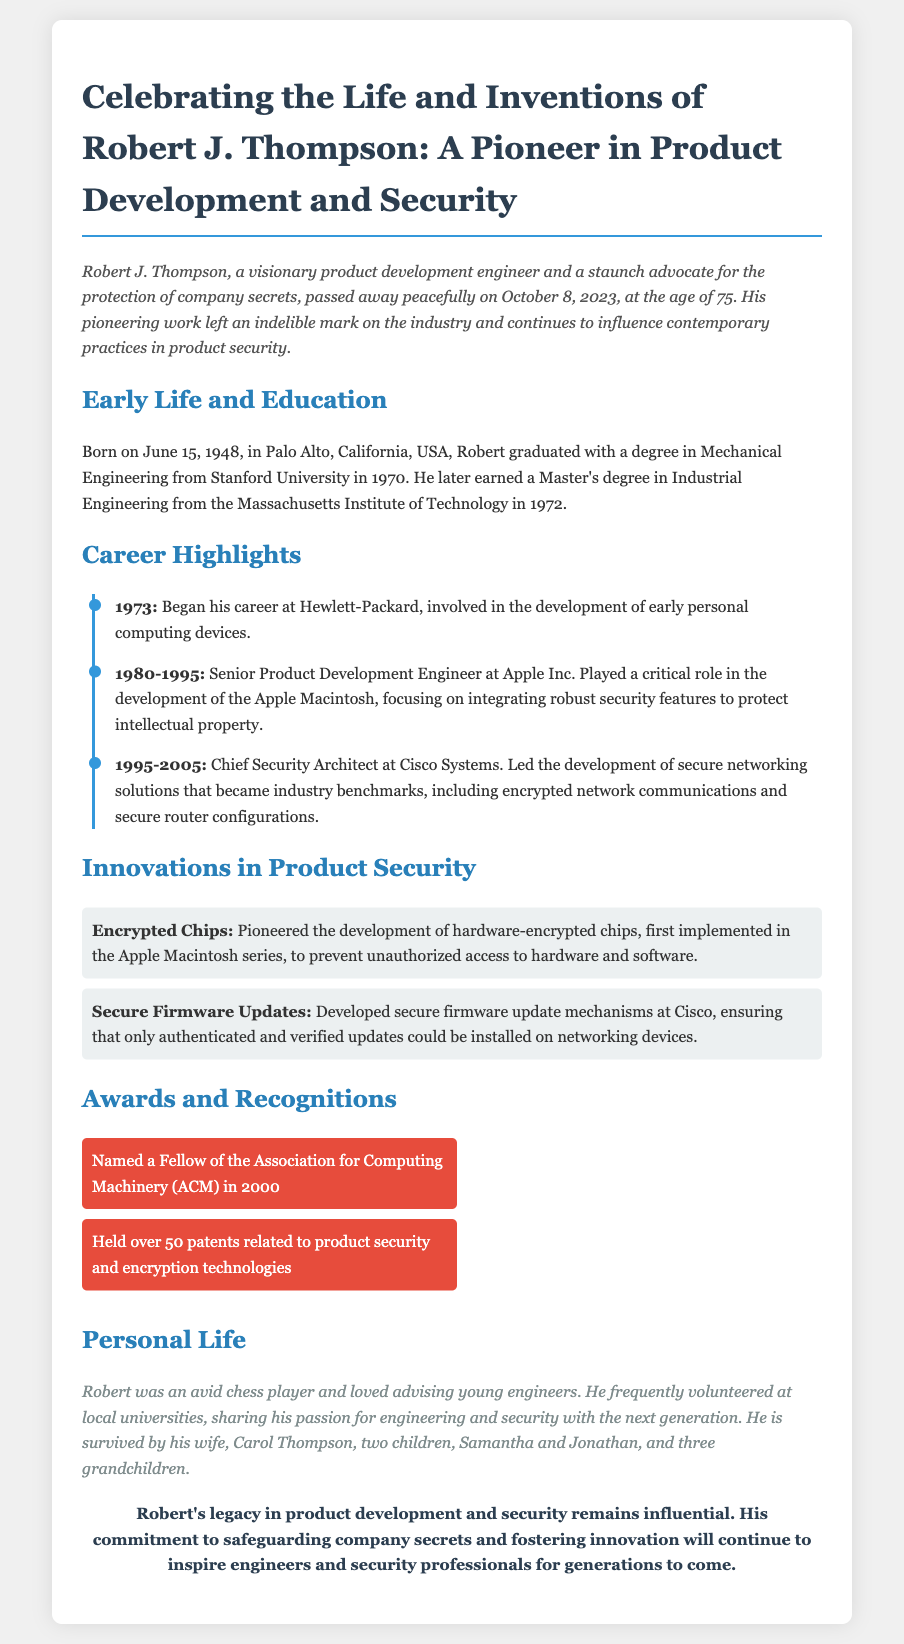What was Robert J. Thompson's birth date? The birth date is mentioned in the Early Life section of the obituary, which states June 15, 1948.
Answer: June 15, 1948 What company did Robert start his career with? The document states that Robert began his career at Hewlett-Packard.
Answer: Hewlett-Packard How many patents did Robert hold related to product security? The document indicates that he held over 50 patents related to product security and encryption technologies.
Answer: Over 50 What significant product did Robert contribute to at Apple Inc.? The obituary mentions that Robert played a critical role in the development of the Apple Macintosh.
Answer: Apple Macintosh What innovative product feature did Robert pioneer in the Apple Macintosh series? The document states that he pioneered the development of hardware-encrypted chips.
Answer: Hardware-encrypted chips What recognition did Robert receive in 2000? The document mentions that he was named a Fellow of the Association for Computing Machinery (ACM) in 2000.
Answer: Fellow of the Association for Computing Machinery (ACM) What was Robert's role at Cisco Systems? According to the document, he was the Chief Security Architect at Cisco Systems.
Answer: Chief Security Architect What was Robert's educational background? The document details that he graduated with a degree in Mechanical Engineering from Stanford University and later earned a Master's in Industrial Engineering from MIT.
Answer: Mechanical Engineering from Stanford University and Industrial Engineering from MIT Who did Robert leave behind? The "Personal Life" section mentions that he is survived by his wife, Carol Thompson, and two children, Samantha and Jonathan, among others.
Answer: His wife Carol, two children Samantha and Jonathan, and three grandchildren 